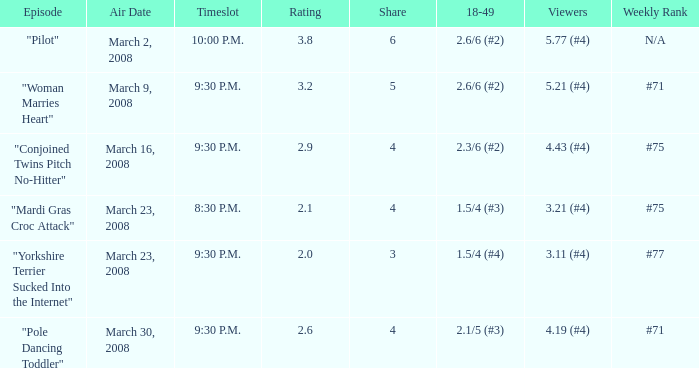What is the cumulative rating for shares below 4? 1.0. 